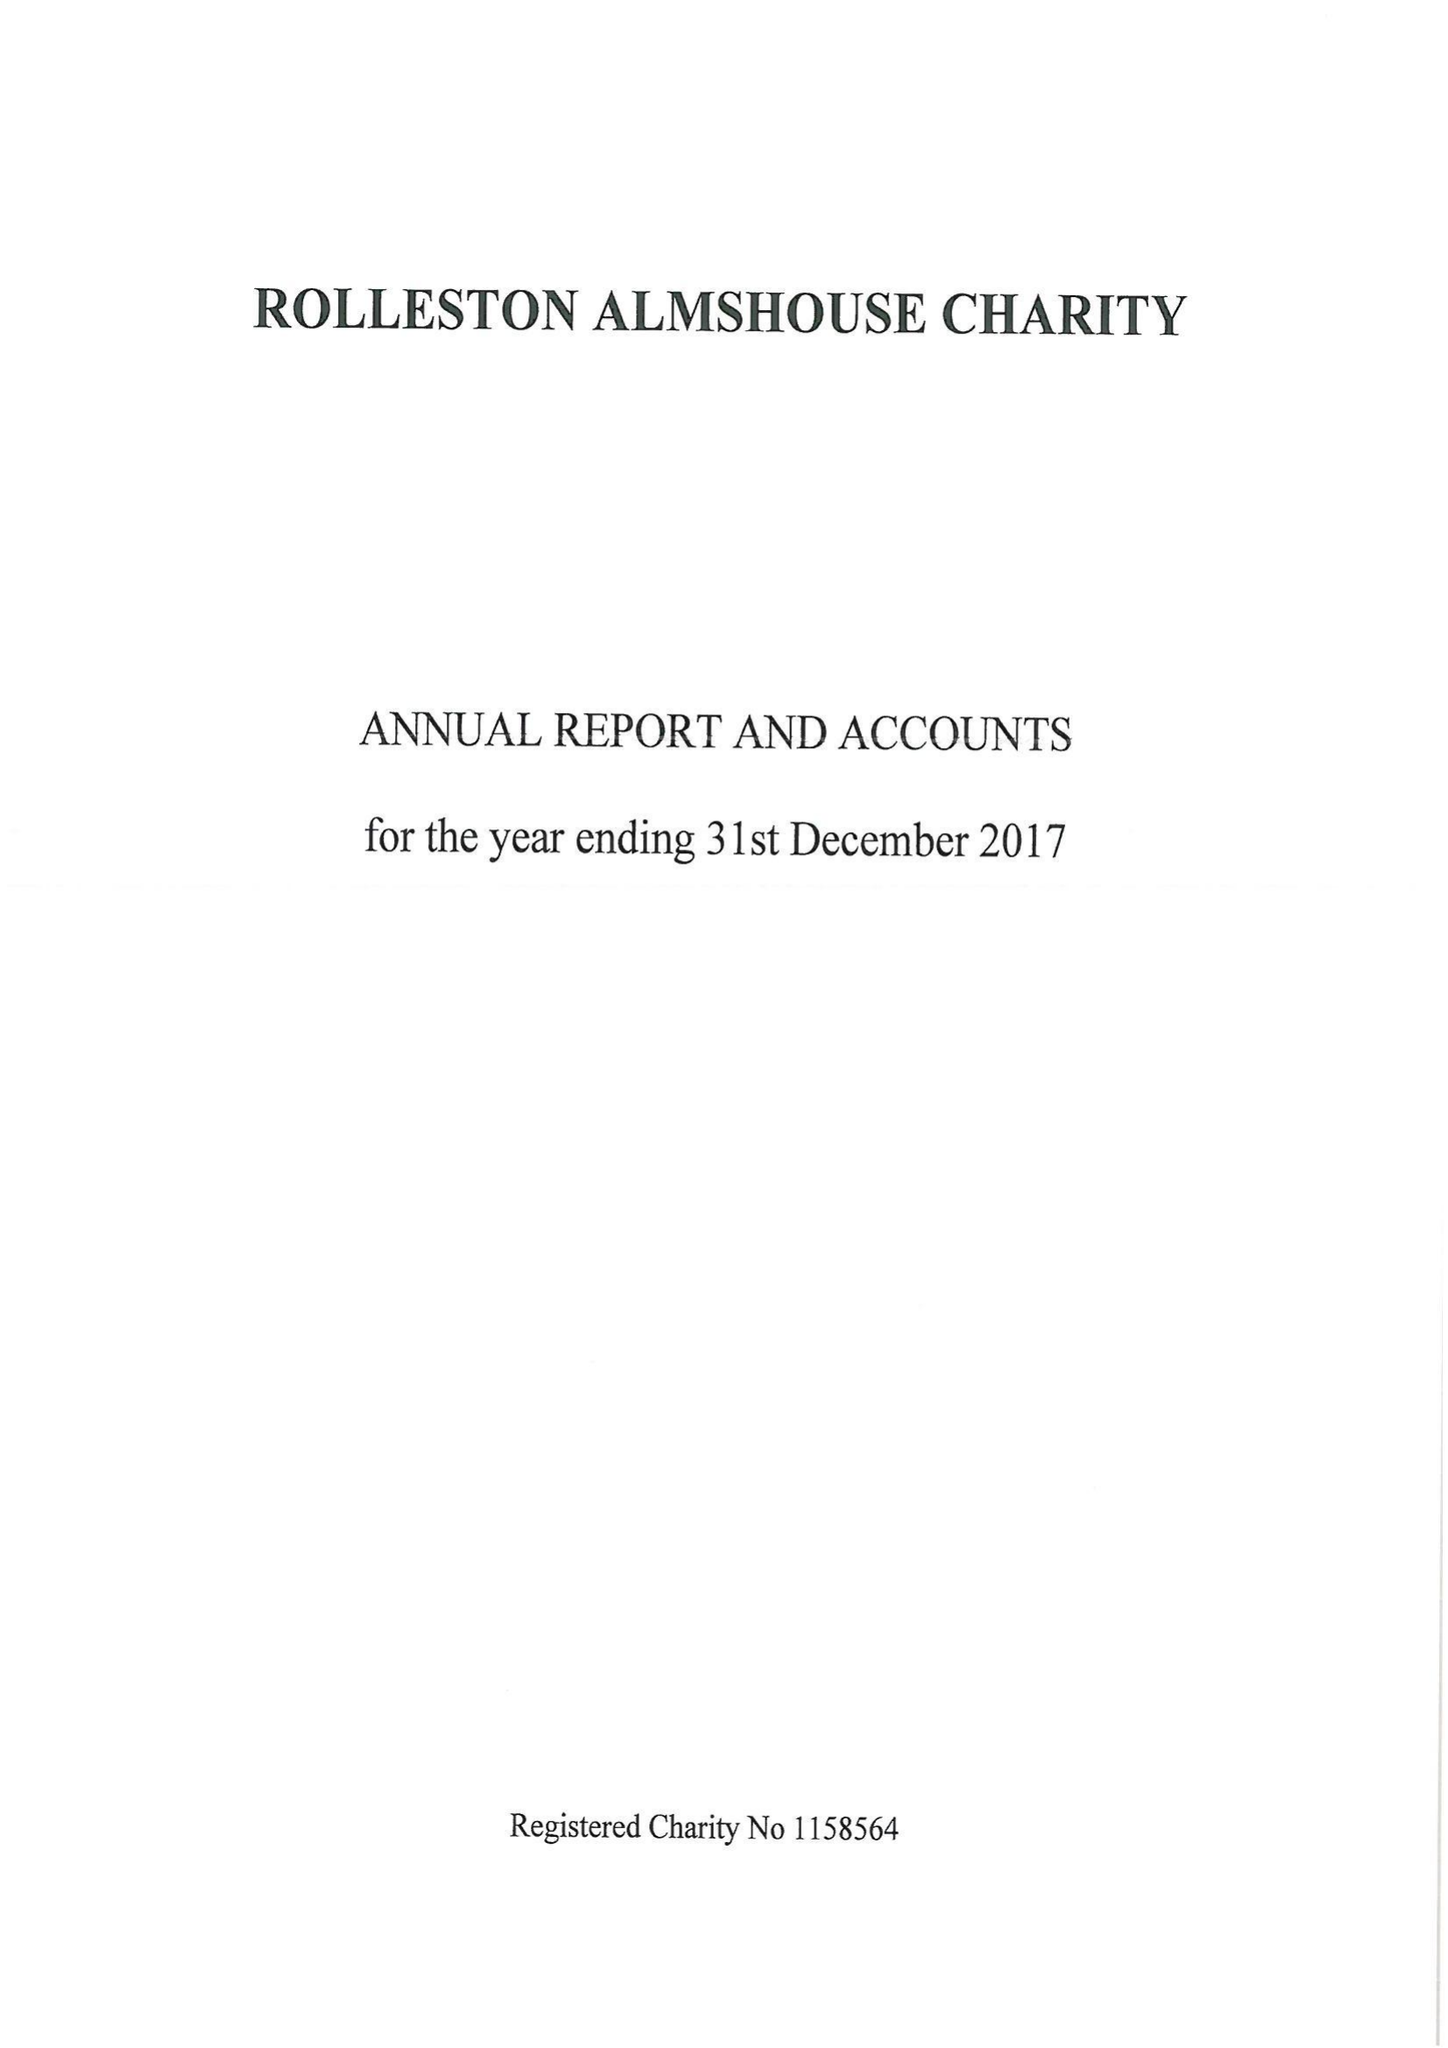What is the value for the address__postcode?
Answer the question using a single word or phrase. DE14 1JY 